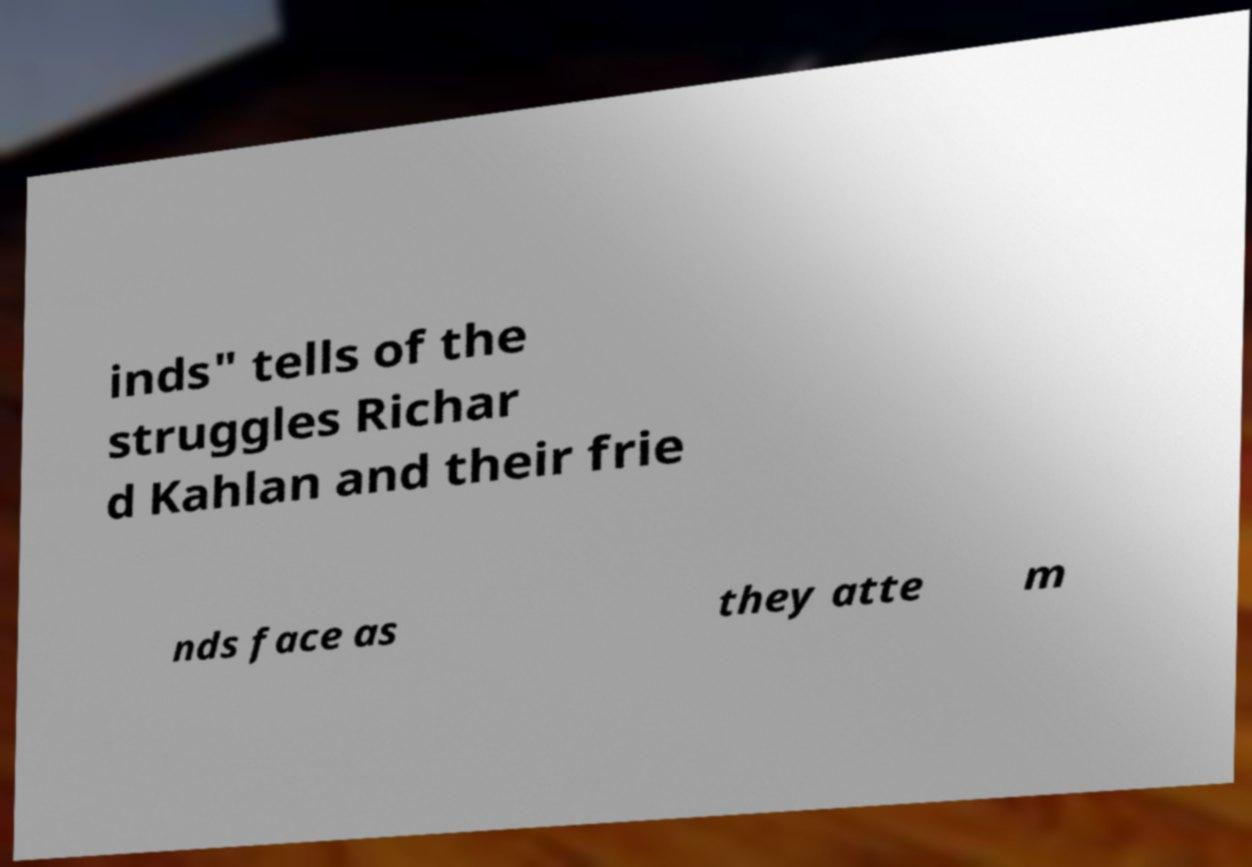I need the written content from this picture converted into text. Can you do that? inds" tells of the struggles Richar d Kahlan and their frie nds face as they atte m 